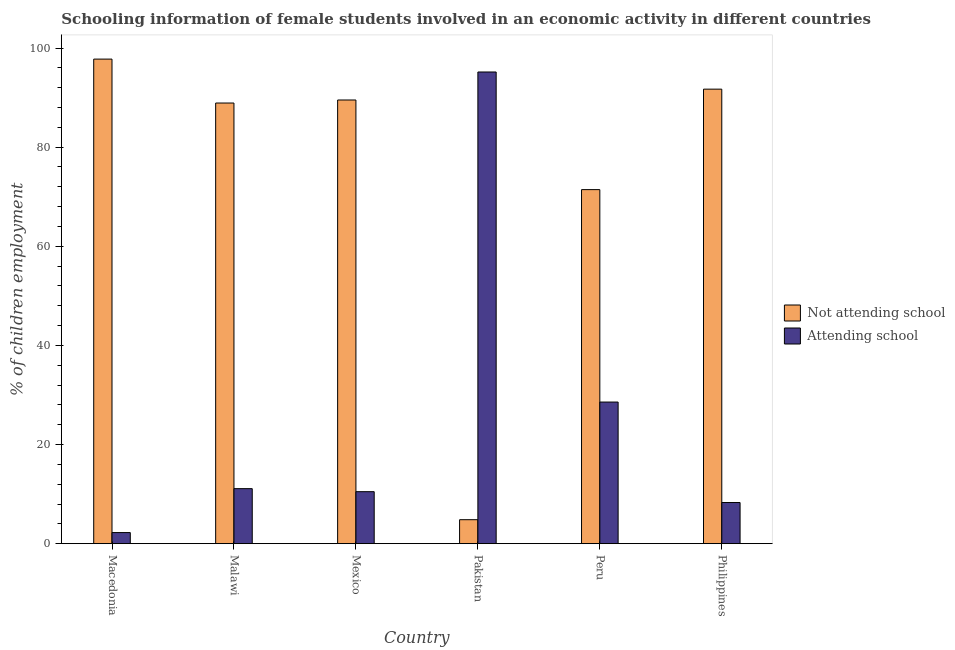How many different coloured bars are there?
Your answer should be compact. 2. Are the number of bars per tick equal to the number of legend labels?
Your response must be concise. Yes. How many bars are there on the 1st tick from the left?
Your answer should be compact. 2. How many bars are there on the 1st tick from the right?
Your response must be concise. 2. In how many cases, is the number of bars for a given country not equal to the number of legend labels?
Offer a very short reply. 0. What is the percentage of employed females who are attending school in Macedonia?
Offer a terse response. 2.24. Across all countries, what is the maximum percentage of employed females who are not attending school?
Give a very brief answer. 97.76. Across all countries, what is the minimum percentage of employed females who are attending school?
Give a very brief answer. 2.24. What is the total percentage of employed females who are not attending school in the graph?
Make the answer very short. 444.14. What is the difference between the percentage of employed females who are not attending school in Macedonia and that in Philippines?
Provide a succinct answer. 6.06. What is the difference between the percentage of employed females who are not attending school in Mexico and the percentage of employed females who are attending school in Pakistan?
Provide a succinct answer. -5.65. What is the average percentage of employed females who are attending school per country?
Ensure brevity in your answer.  25.98. What is the difference between the percentage of employed females who are attending school and percentage of employed females who are not attending school in Malawi?
Offer a very short reply. -77.8. In how many countries, is the percentage of employed females who are not attending school greater than 28 %?
Offer a very short reply. 5. What is the ratio of the percentage of employed females who are attending school in Macedonia to that in Pakistan?
Provide a short and direct response. 0.02. What is the difference between the highest and the second highest percentage of employed females who are not attending school?
Your response must be concise. 6.06. What is the difference between the highest and the lowest percentage of employed females who are attending school?
Give a very brief answer. 92.93. In how many countries, is the percentage of employed females who are attending school greater than the average percentage of employed females who are attending school taken over all countries?
Your answer should be very brief. 2. Is the sum of the percentage of employed females who are not attending school in Mexico and Pakistan greater than the maximum percentage of employed females who are attending school across all countries?
Make the answer very short. No. What does the 2nd bar from the left in Philippines represents?
Offer a terse response. Attending school. What does the 1st bar from the right in Peru represents?
Provide a short and direct response. Attending school. Are all the bars in the graph horizontal?
Your answer should be very brief. No. Are the values on the major ticks of Y-axis written in scientific E-notation?
Offer a very short reply. No. Does the graph contain grids?
Your response must be concise. No. How are the legend labels stacked?
Provide a short and direct response. Vertical. What is the title of the graph?
Give a very brief answer. Schooling information of female students involved in an economic activity in different countries. Does "Largest city" appear as one of the legend labels in the graph?
Provide a short and direct response. No. What is the label or title of the X-axis?
Offer a terse response. Country. What is the label or title of the Y-axis?
Offer a very short reply. % of children employment. What is the % of children employment in Not attending school in Macedonia?
Give a very brief answer. 97.76. What is the % of children employment in Attending school in Macedonia?
Ensure brevity in your answer.  2.24. What is the % of children employment in Not attending school in Malawi?
Ensure brevity in your answer.  88.9. What is the % of children employment in Attending school in Malawi?
Your answer should be compact. 11.1. What is the % of children employment in Not attending school in Mexico?
Give a very brief answer. 89.51. What is the % of children employment of Attending school in Mexico?
Keep it short and to the point. 10.49. What is the % of children employment of Not attending school in Pakistan?
Make the answer very short. 4.84. What is the % of children employment of Attending school in Pakistan?
Provide a short and direct response. 95.16. What is the % of children employment in Not attending school in Peru?
Provide a succinct answer. 71.43. What is the % of children employment in Attending school in Peru?
Your response must be concise. 28.57. What is the % of children employment of Not attending school in Philippines?
Provide a succinct answer. 91.7. What is the % of children employment of Attending school in Philippines?
Keep it short and to the point. 8.3. Across all countries, what is the maximum % of children employment of Not attending school?
Provide a succinct answer. 97.76. Across all countries, what is the maximum % of children employment of Attending school?
Offer a very short reply. 95.16. Across all countries, what is the minimum % of children employment in Not attending school?
Your response must be concise. 4.84. Across all countries, what is the minimum % of children employment of Attending school?
Ensure brevity in your answer.  2.24. What is the total % of children employment in Not attending school in the graph?
Provide a succinct answer. 444.14. What is the total % of children employment in Attending school in the graph?
Make the answer very short. 155.86. What is the difference between the % of children employment of Not attending school in Macedonia and that in Malawi?
Provide a short and direct response. 8.86. What is the difference between the % of children employment in Attending school in Macedonia and that in Malawi?
Offer a very short reply. -8.86. What is the difference between the % of children employment in Not attending school in Macedonia and that in Mexico?
Your answer should be very brief. 8.25. What is the difference between the % of children employment in Attending school in Macedonia and that in Mexico?
Ensure brevity in your answer.  -8.25. What is the difference between the % of children employment in Not attending school in Macedonia and that in Pakistan?
Provide a short and direct response. 92.93. What is the difference between the % of children employment in Attending school in Macedonia and that in Pakistan?
Make the answer very short. -92.93. What is the difference between the % of children employment in Not attending school in Macedonia and that in Peru?
Your response must be concise. 26.33. What is the difference between the % of children employment in Attending school in Macedonia and that in Peru?
Provide a short and direct response. -26.33. What is the difference between the % of children employment in Not attending school in Macedonia and that in Philippines?
Offer a very short reply. 6.06. What is the difference between the % of children employment in Attending school in Macedonia and that in Philippines?
Your answer should be compact. -6.06. What is the difference between the % of children employment of Not attending school in Malawi and that in Mexico?
Provide a short and direct response. -0.61. What is the difference between the % of children employment in Attending school in Malawi and that in Mexico?
Your response must be concise. 0.61. What is the difference between the % of children employment in Not attending school in Malawi and that in Pakistan?
Ensure brevity in your answer.  84.06. What is the difference between the % of children employment of Attending school in Malawi and that in Pakistan?
Provide a succinct answer. -84.06. What is the difference between the % of children employment of Not attending school in Malawi and that in Peru?
Make the answer very short. 17.47. What is the difference between the % of children employment in Attending school in Malawi and that in Peru?
Your response must be concise. -17.47. What is the difference between the % of children employment in Not attending school in Malawi and that in Philippines?
Offer a terse response. -2.8. What is the difference between the % of children employment of Attending school in Malawi and that in Philippines?
Your answer should be compact. 2.8. What is the difference between the % of children employment in Not attending school in Mexico and that in Pakistan?
Keep it short and to the point. 84.68. What is the difference between the % of children employment of Attending school in Mexico and that in Pakistan?
Offer a terse response. -84.68. What is the difference between the % of children employment in Not attending school in Mexico and that in Peru?
Your response must be concise. 18.08. What is the difference between the % of children employment of Attending school in Mexico and that in Peru?
Make the answer very short. -18.08. What is the difference between the % of children employment in Not attending school in Mexico and that in Philippines?
Provide a succinct answer. -2.19. What is the difference between the % of children employment of Attending school in Mexico and that in Philippines?
Make the answer very short. 2.19. What is the difference between the % of children employment of Not attending school in Pakistan and that in Peru?
Ensure brevity in your answer.  -66.59. What is the difference between the % of children employment in Attending school in Pakistan and that in Peru?
Your answer should be compact. 66.59. What is the difference between the % of children employment in Not attending school in Pakistan and that in Philippines?
Ensure brevity in your answer.  -86.86. What is the difference between the % of children employment in Attending school in Pakistan and that in Philippines?
Provide a short and direct response. 86.86. What is the difference between the % of children employment of Not attending school in Peru and that in Philippines?
Your response must be concise. -20.27. What is the difference between the % of children employment in Attending school in Peru and that in Philippines?
Ensure brevity in your answer.  20.27. What is the difference between the % of children employment of Not attending school in Macedonia and the % of children employment of Attending school in Malawi?
Give a very brief answer. 86.66. What is the difference between the % of children employment of Not attending school in Macedonia and the % of children employment of Attending school in Mexico?
Ensure brevity in your answer.  87.28. What is the difference between the % of children employment of Not attending school in Macedonia and the % of children employment of Attending school in Pakistan?
Your answer should be very brief. 2.6. What is the difference between the % of children employment of Not attending school in Macedonia and the % of children employment of Attending school in Peru?
Keep it short and to the point. 69.19. What is the difference between the % of children employment of Not attending school in Macedonia and the % of children employment of Attending school in Philippines?
Your answer should be very brief. 89.46. What is the difference between the % of children employment of Not attending school in Malawi and the % of children employment of Attending school in Mexico?
Your answer should be very brief. 78.41. What is the difference between the % of children employment of Not attending school in Malawi and the % of children employment of Attending school in Pakistan?
Provide a short and direct response. -6.26. What is the difference between the % of children employment in Not attending school in Malawi and the % of children employment in Attending school in Peru?
Your response must be concise. 60.33. What is the difference between the % of children employment of Not attending school in Malawi and the % of children employment of Attending school in Philippines?
Offer a very short reply. 80.6. What is the difference between the % of children employment of Not attending school in Mexico and the % of children employment of Attending school in Pakistan?
Ensure brevity in your answer.  -5.65. What is the difference between the % of children employment of Not attending school in Mexico and the % of children employment of Attending school in Peru?
Ensure brevity in your answer.  60.94. What is the difference between the % of children employment in Not attending school in Mexico and the % of children employment in Attending school in Philippines?
Your response must be concise. 81.21. What is the difference between the % of children employment of Not attending school in Pakistan and the % of children employment of Attending school in Peru?
Provide a short and direct response. -23.73. What is the difference between the % of children employment of Not attending school in Pakistan and the % of children employment of Attending school in Philippines?
Keep it short and to the point. -3.46. What is the difference between the % of children employment of Not attending school in Peru and the % of children employment of Attending school in Philippines?
Your answer should be very brief. 63.13. What is the average % of children employment of Not attending school per country?
Make the answer very short. 74.02. What is the average % of children employment of Attending school per country?
Provide a short and direct response. 25.98. What is the difference between the % of children employment of Not attending school and % of children employment of Attending school in Macedonia?
Your response must be concise. 95.53. What is the difference between the % of children employment in Not attending school and % of children employment in Attending school in Malawi?
Your response must be concise. 77.8. What is the difference between the % of children employment in Not attending school and % of children employment in Attending school in Mexico?
Provide a succinct answer. 79.03. What is the difference between the % of children employment in Not attending school and % of children employment in Attending school in Pakistan?
Provide a succinct answer. -90.33. What is the difference between the % of children employment of Not attending school and % of children employment of Attending school in Peru?
Your answer should be very brief. 42.86. What is the difference between the % of children employment in Not attending school and % of children employment in Attending school in Philippines?
Provide a short and direct response. 83.4. What is the ratio of the % of children employment in Not attending school in Macedonia to that in Malawi?
Provide a succinct answer. 1.1. What is the ratio of the % of children employment of Attending school in Macedonia to that in Malawi?
Make the answer very short. 0.2. What is the ratio of the % of children employment of Not attending school in Macedonia to that in Mexico?
Keep it short and to the point. 1.09. What is the ratio of the % of children employment in Attending school in Macedonia to that in Mexico?
Offer a very short reply. 0.21. What is the ratio of the % of children employment of Not attending school in Macedonia to that in Pakistan?
Keep it short and to the point. 20.21. What is the ratio of the % of children employment in Attending school in Macedonia to that in Pakistan?
Offer a terse response. 0.02. What is the ratio of the % of children employment in Not attending school in Macedonia to that in Peru?
Offer a very short reply. 1.37. What is the ratio of the % of children employment in Attending school in Macedonia to that in Peru?
Give a very brief answer. 0.08. What is the ratio of the % of children employment of Not attending school in Macedonia to that in Philippines?
Provide a short and direct response. 1.07. What is the ratio of the % of children employment of Attending school in Macedonia to that in Philippines?
Make the answer very short. 0.27. What is the ratio of the % of children employment in Not attending school in Malawi to that in Mexico?
Make the answer very short. 0.99. What is the ratio of the % of children employment of Attending school in Malawi to that in Mexico?
Make the answer very short. 1.06. What is the ratio of the % of children employment of Not attending school in Malawi to that in Pakistan?
Offer a very short reply. 18.38. What is the ratio of the % of children employment of Attending school in Malawi to that in Pakistan?
Make the answer very short. 0.12. What is the ratio of the % of children employment of Not attending school in Malawi to that in Peru?
Offer a terse response. 1.24. What is the ratio of the % of children employment in Attending school in Malawi to that in Peru?
Your answer should be compact. 0.39. What is the ratio of the % of children employment in Not attending school in Malawi to that in Philippines?
Make the answer very short. 0.97. What is the ratio of the % of children employment in Attending school in Malawi to that in Philippines?
Provide a succinct answer. 1.34. What is the ratio of the % of children employment in Not attending school in Mexico to that in Pakistan?
Your answer should be very brief. 18.51. What is the ratio of the % of children employment in Attending school in Mexico to that in Pakistan?
Your answer should be compact. 0.11. What is the ratio of the % of children employment of Not attending school in Mexico to that in Peru?
Give a very brief answer. 1.25. What is the ratio of the % of children employment in Attending school in Mexico to that in Peru?
Your answer should be compact. 0.37. What is the ratio of the % of children employment of Not attending school in Mexico to that in Philippines?
Your response must be concise. 0.98. What is the ratio of the % of children employment of Attending school in Mexico to that in Philippines?
Offer a terse response. 1.26. What is the ratio of the % of children employment in Not attending school in Pakistan to that in Peru?
Offer a terse response. 0.07. What is the ratio of the % of children employment in Attending school in Pakistan to that in Peru?
Give a very brief answer. 3.33. What is the ratio of the % of children employment in Not attending school in Pakistan to that in Philippines?
Give a very brief answer. 0.05. What is the ratio of the % of children employment in Attending school in Pakistan to that in Philippines?
Your response must be concise. 11.47. What is the ratio of the % of children employment in Not attending school in Peru to that in Philippines?
Offer a very short reply. 0.78. What is the ratio of the % of children employment of Attending school in Peru to that in Philippines?
Your response must be concise. 3.44. What is the difference between the highest and the second highest % of children employment in Not attending school?
Your answer should be compact. 6.06. What is the difference between the highest and the second highest % of children employment of Attending school?
Your answer should be compact. 66.59. What is the difference between the highest and the lowest % of children employment in Not attending school?
Provide a short and direct response. 92.93. What is the difference between the highest and the lowest % of children employment of Attending school?
Give a very brief answer. 92.93. 